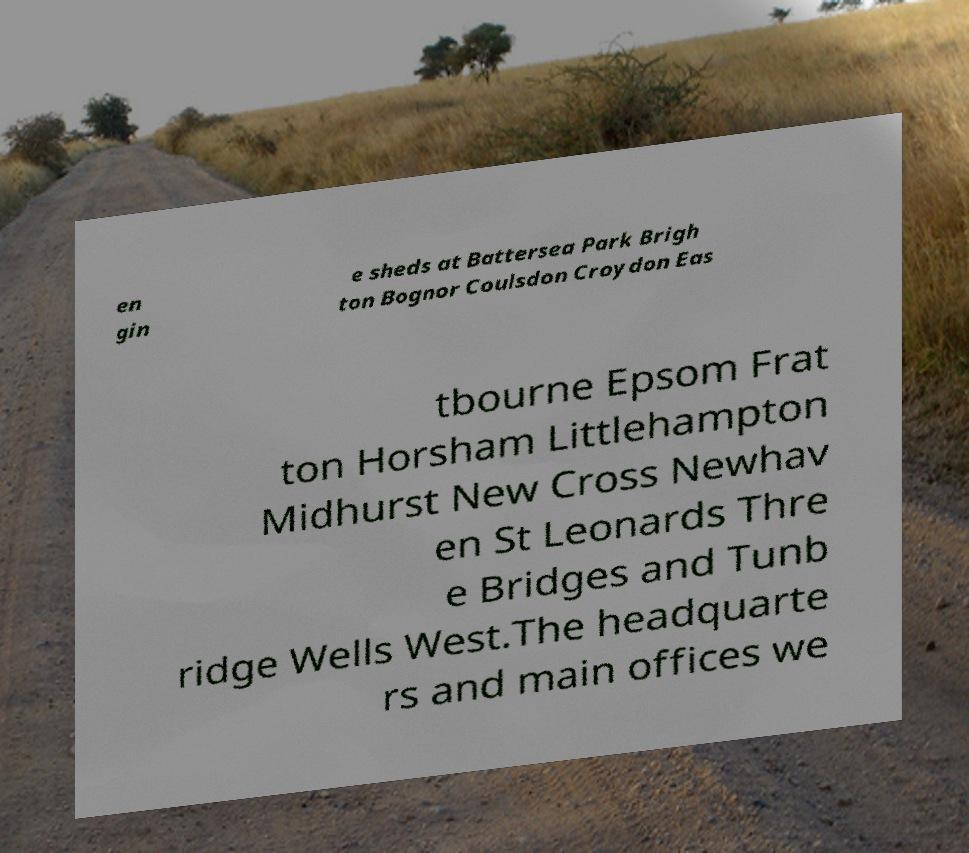I need the written content from this picture converted into text. Can you do that? en gin e sheds at Battersea Park Brigh ton Bognor Coulsdon Croydon Eas tbourne Epsom Frat ton Horsham Littlehampton Midhurst New Cross Newhav en St Leonards Thre e Bridges and Tunb ridge Wells West.The headquarte rs and main offices we 